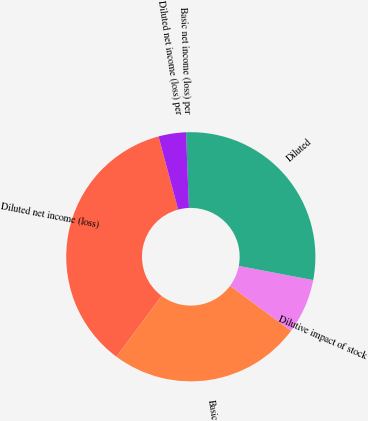Convert chart. <chart><loc_0><loc_0><loc_500><loc_500><pie_chart><fcel>Diluted net income (loss)<fcel>Basic<fcel>Dilutive impact of stock<fcel>Diluted<fcel>Basic net income (loss) per<fcel>Diluted net income (loss) per<nl><fcel>35.65%<fcel>25.05%<fcel>7.13%<fcel>28.61%<fcel>0.0%<fcel>3.56%<nl></chart> 